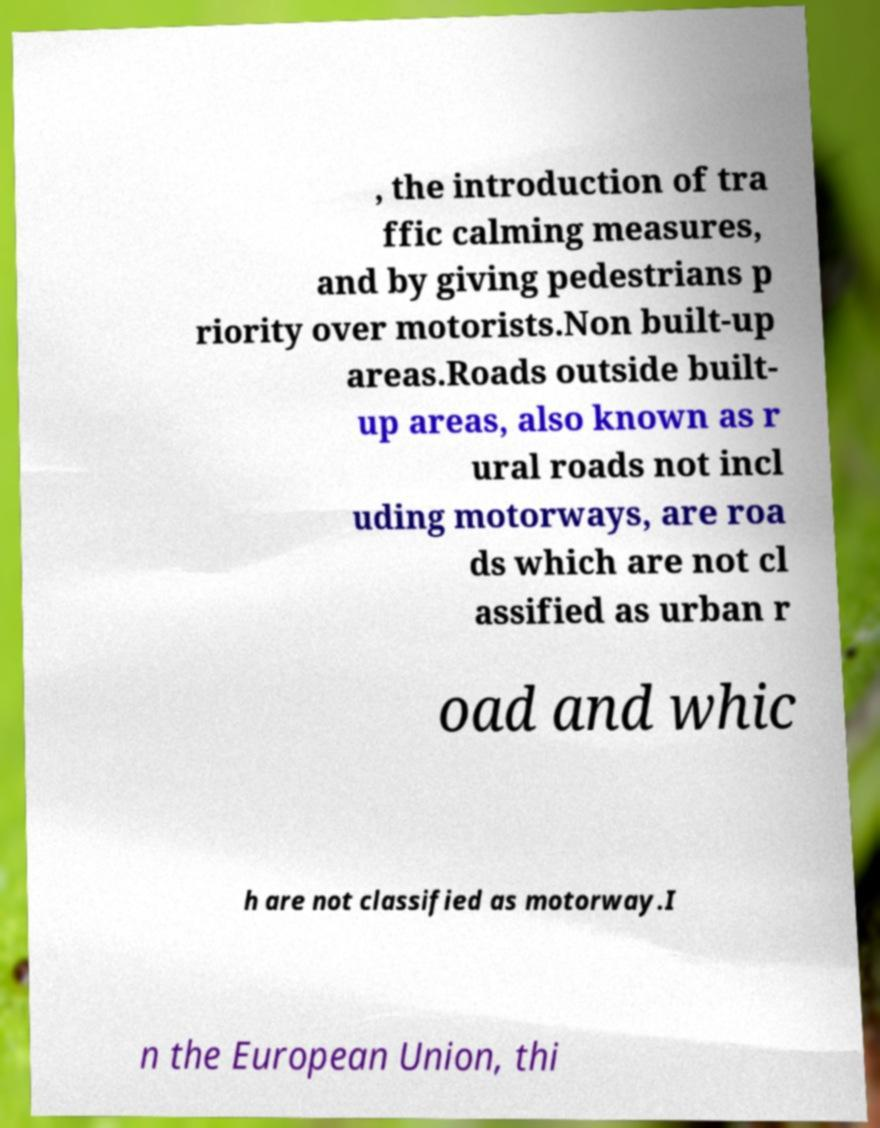Please identify and transcribe the text found in this image. , the introduction of tra ffic calming measures, and by giving pedestrians p riority over motorists.Non built-up areas.Roads outside built- up areas, also known as r ural roads not incl uding motorways, are roa ds which are not cl assified as urban r oad and whic h are not classified as motorway.I n the European Union, thi 